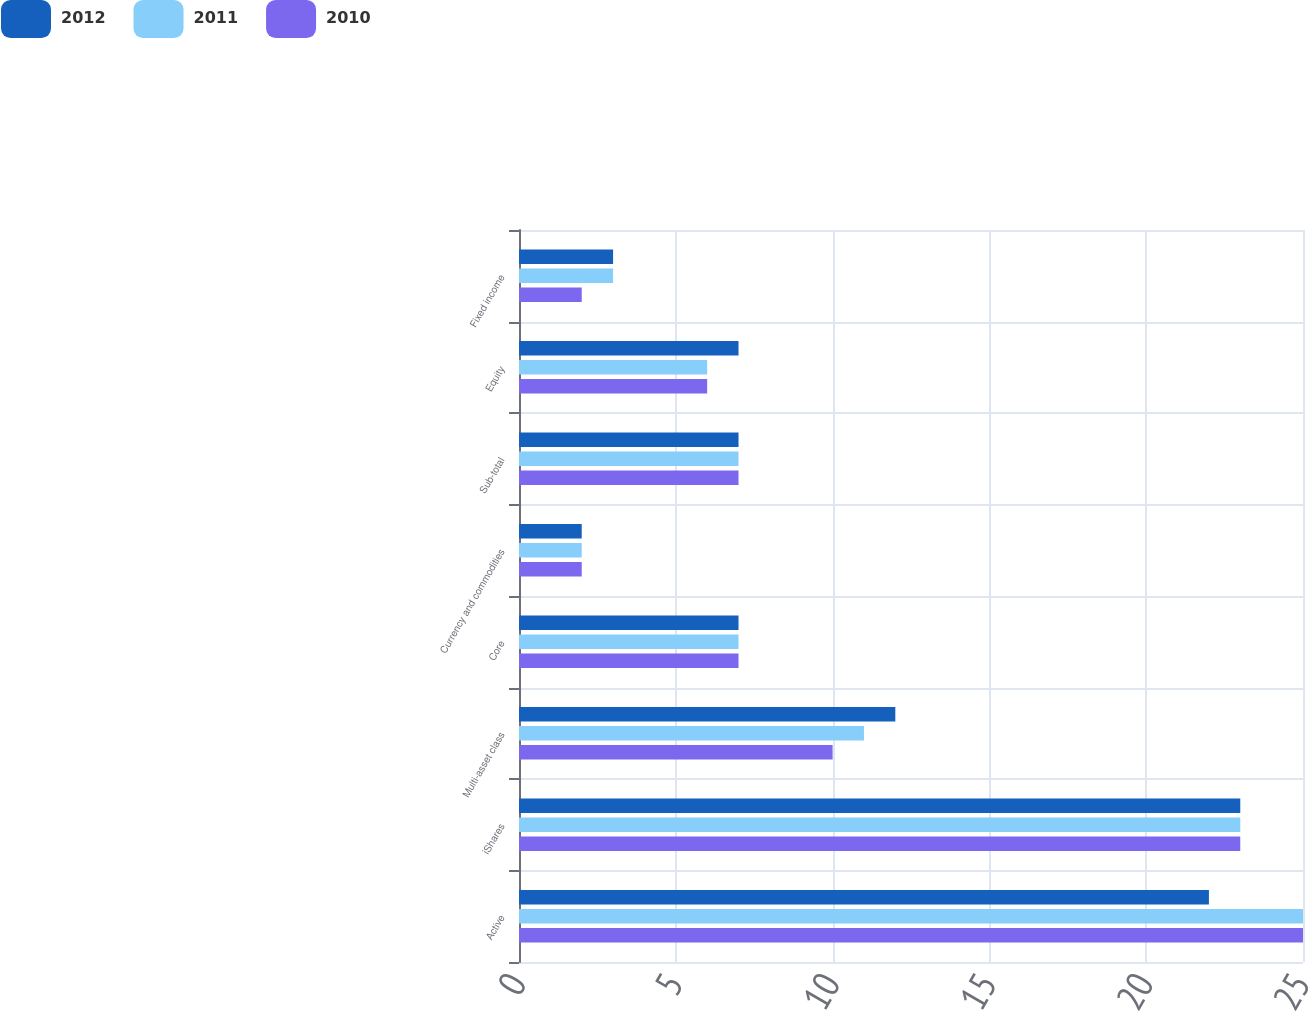<chart> <loc_0><loc_0><loc_500><loc_500><stacked_bar_chart><ecel><fcel>Active<fcel>iShares<fcel>Multi-asset class<fcel>Core<fcel>Currency and commodities<fcel>Sub-total<fcel>Equity<fcel>Fixed income<nl><fcel>2012<fcel>22<fcel>23<fcel>12<fcel>7<fcel>2<fcel>7<fcel>7<fcel>3<nl><fcel>2011<fcel>25<fcel>23<fcel>11<fcel>7<fcel>2<fcel>7<fcel>6<fcel>3<nl><fcel>2010<fcel>25<fcel>23<fcel>10<fcel>7<fcel>2<fcel>7<fcel>6<fcel>2<nl></chart> 